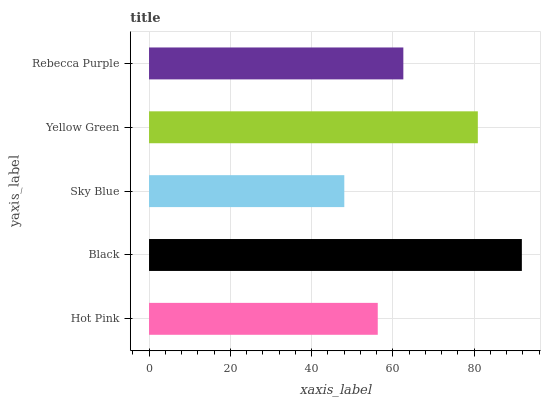Is Sky Blue the minimum?
Answer yes or no. Yes. Is Black the maximum?
Answer yes or no. Yes. Is Black the minimum?
Answer yes or no. No. Is Sky Blue the maximum?
Answer yes or no. No. Is Black greater than Sky Blue?
Answer yes or no. Yes. Is Sky Blue less than Black?
Answer yes or no. Yes. Is Sky Blue greater than Black?
Answer yes or no. No. Is Black less than Sky Blue?
Answer yes or no. No. Is Rebecca Purple the high median?
Answer yes or no. Yes. Is Rebecca Purple the low median?
Answer yes or no. Yes. Is Black the high median?
Answer yes or no. No. Is Yellow Green the low median?
Answer yes or no. No. 